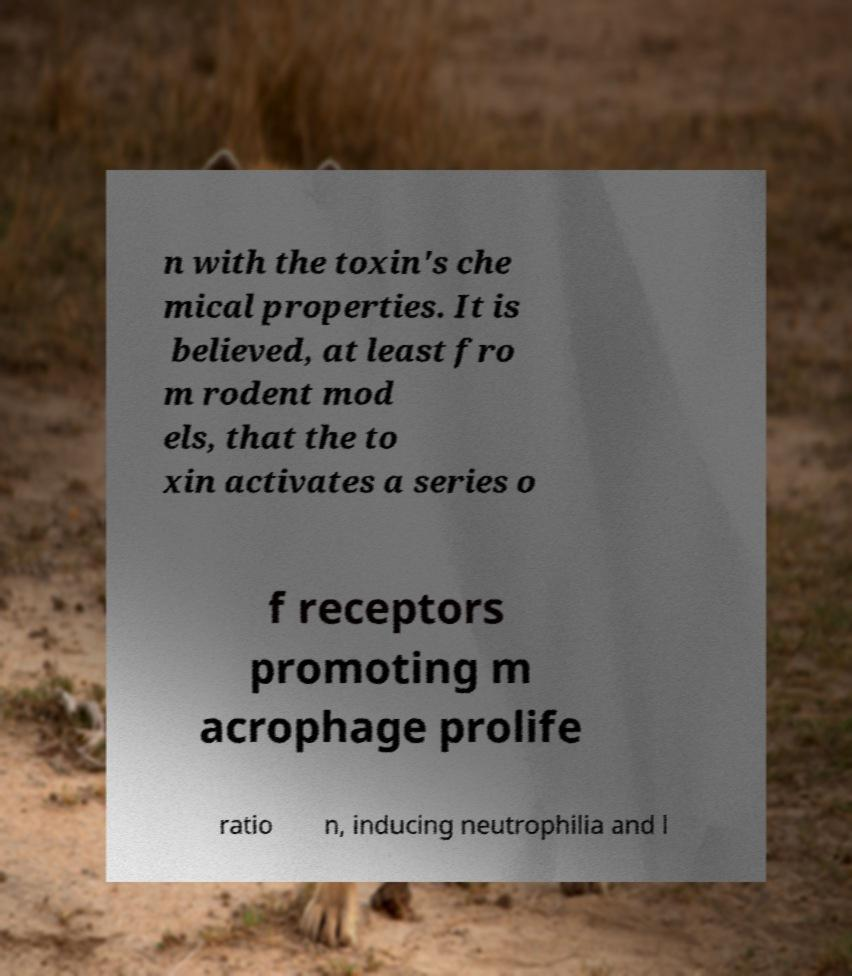Can you accurately transcribe the text from the provided image for me? n with the toxin's che mical properties. It is believed, at least fro m rodent mod els, that the to xin activates a series o f receptors promoting m acrophage prolife ratio n, inducing neutrophilia and l 